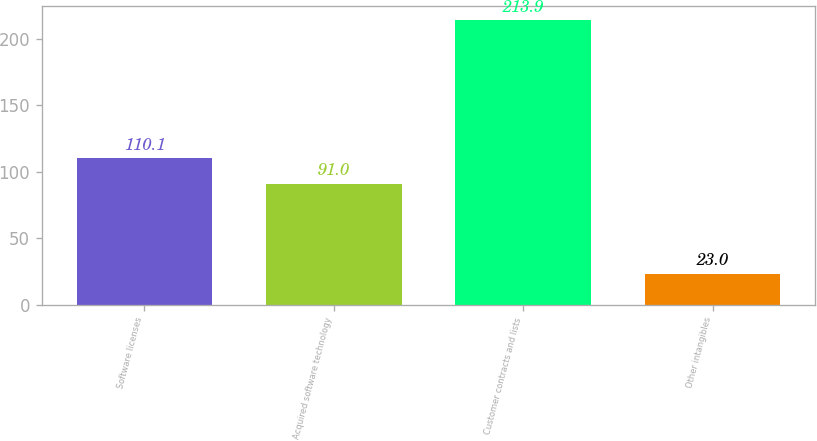Convert chart. <chart><loc_0><loc_0><loc_500><loc_500><bar_chart><fcel>Software licenses<fcel>Acquired software technology<fcel>Customer contracts and lists<fcel>Other intangibles<nl><fcel>110.1<fcel>91<fcel>213.9<fcel>23<nl></chart> 